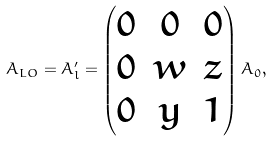Convert formula to latex. <formula><loc_0><loc_0><loc_500><loc_500>A _ { L O } = A ^ { \prime } _ { l } = \begin{pmatrix} 0 & 0 & 0 \\ 0 & w & z \\ 0 & y & 1 \end{pmatrix} A _ { 0 } ,</formula> 